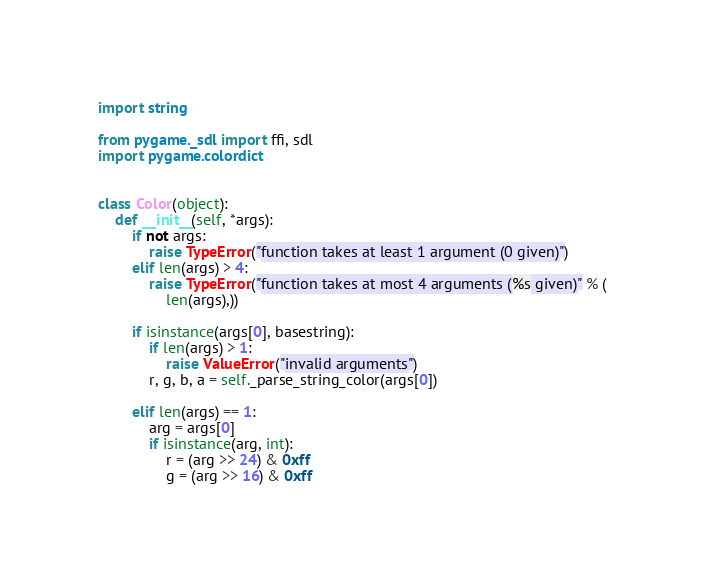<code> <loc_0><loc_0><loc_500><loc_500><_Python_>import string

from pygame._sdl import ffi, sdl
import pygame.colordict


class Color(object):
    def __init__(self, *args):
        if not args:
            raise TypeError("function takes at least 1 argument (0 given)")
        elif len(args) > 4:
            raise TypeError("function takes at most 4 arguments (%s given)" % (
                len(args),))

        if isinstance(args[0], basestring):
            if len(args) > 1:
                raise ValueError("invalid arguments")
            r, g, b, a = self._parse_string_color(args[0])

        elif len(args) == 1:
            arg = args[0]
            if isinstance(arg, int):
                r = (arg >> 24) & 0xff
                g = (arg >> 16) & 0xff</code> 